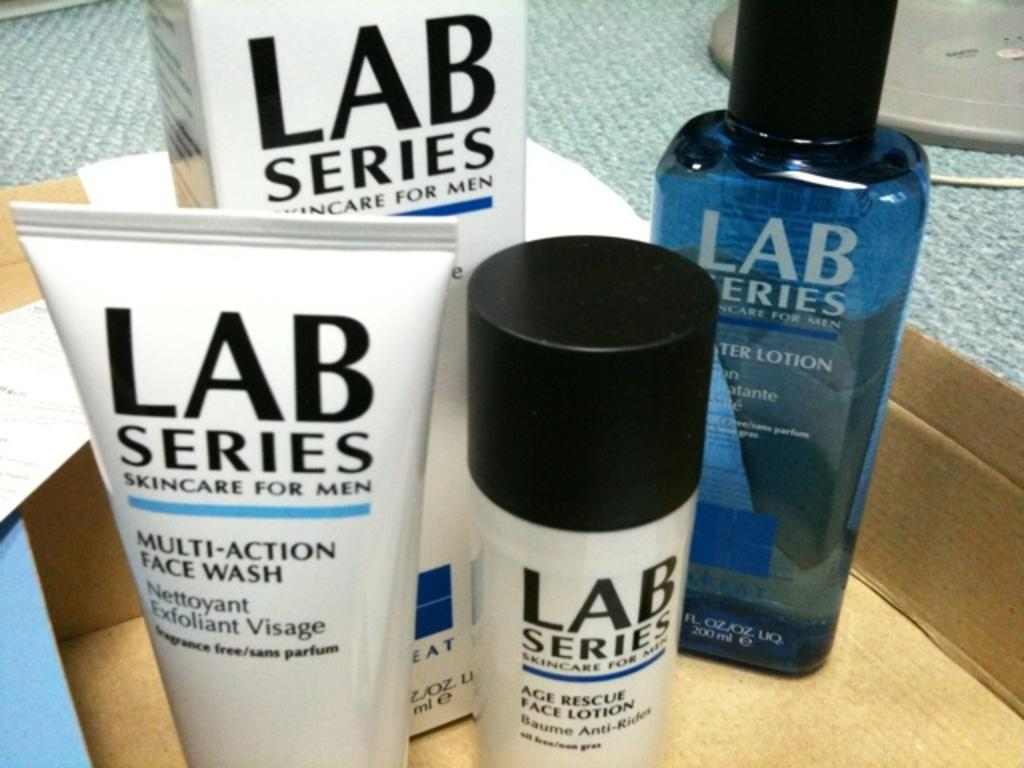<image>
Describe the image concisely. a set of skin care products with the name Lab series. 